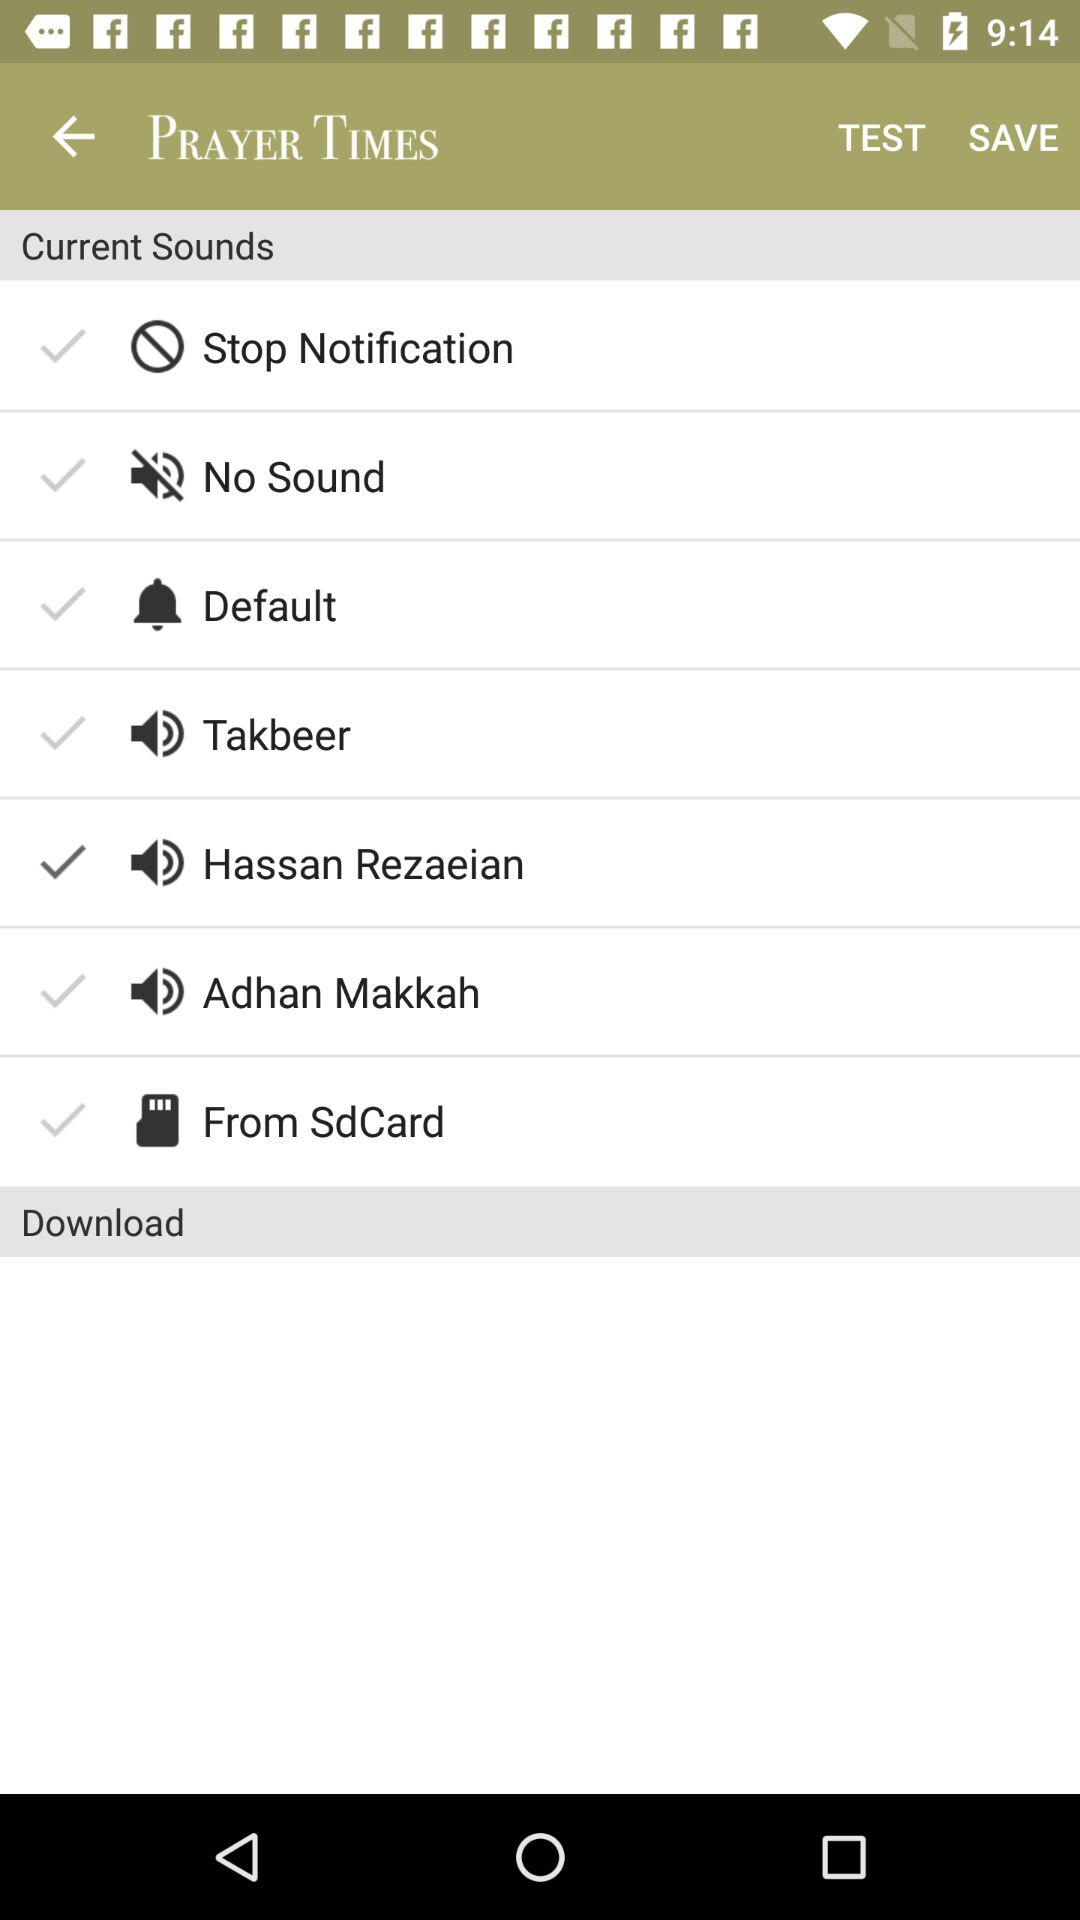Is the "No Sound" setting selected or not? The "No Sound" setting is not selected. 